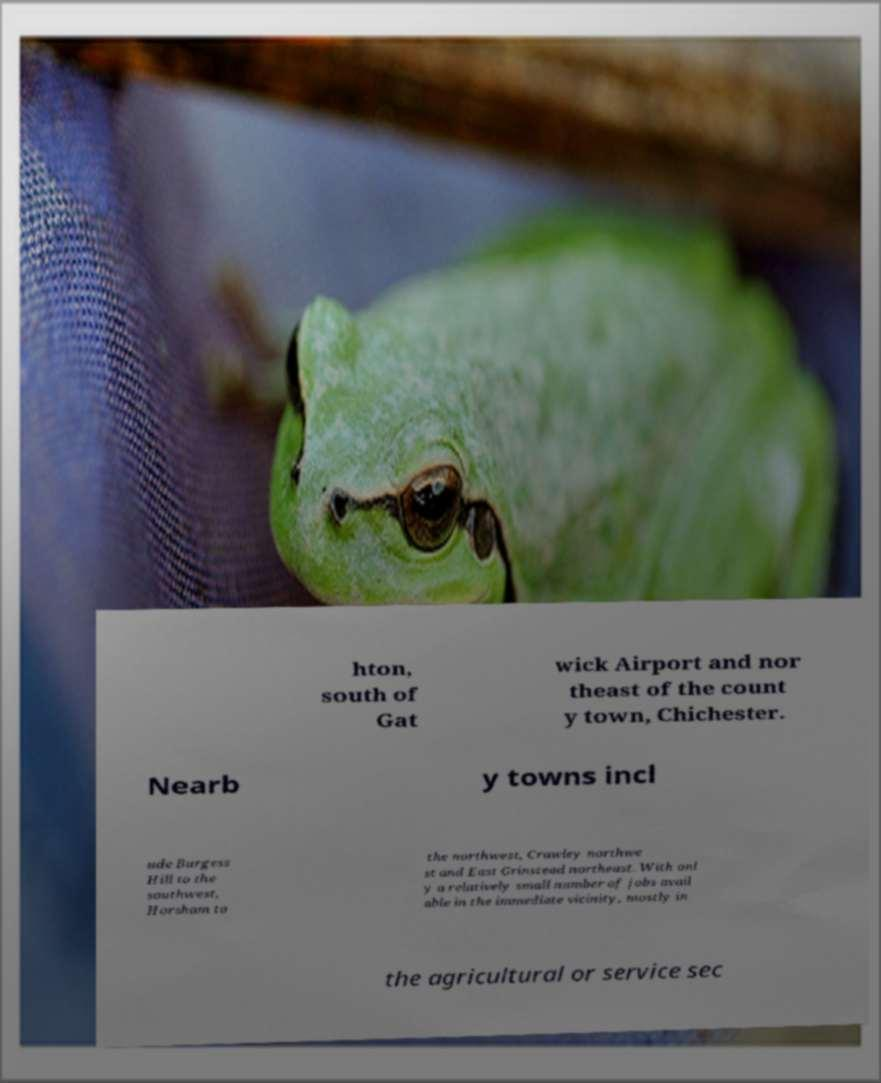Please read and relay the text visible in this image. What does it say? hton, south of Gat wick Airport and nor theast of the count y town, Chichester. Nearb y towns incl ude Burgess Hill to the southwest, Horsham to the northwest, Crawley northwe st and East Grinstead northeast. With onl y a relatively small number of jobs avail able in the immediate vicinity, mostly in the agricultural or service sec 